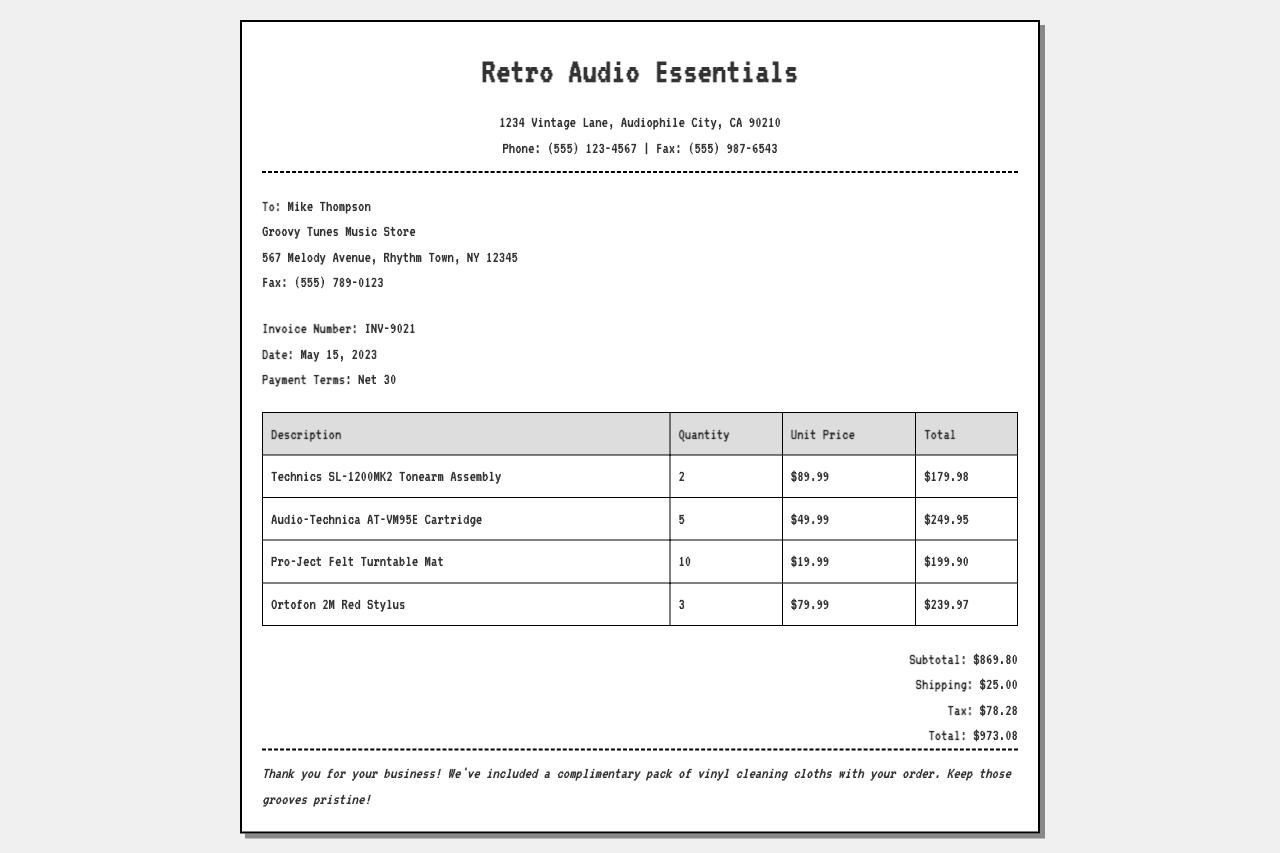What is the invoice number? The invoice number is prominently displayed in the document details.
Answer: INV-9021 What date was the invoice issued? The date of the invoice is given in the invoice details section.
Answer: May 15, 2023 Who is the recipient of the invoice? The recipient's name is listed as the first item in the recipient section.
Answer: Mike Thompson What is the subtotal amount? The subtotal amount is calculated and shown in the totals section.
Answer: $869.80 How many Audio-Technica AT-VM95E Cartridges were ordered? The quantity is indicated in the table under the specified product.
Answer: 5 What is the total amount due? The total is clearly stated in the totals section of the document.
Answer: $973.08 What is included as a complimentary item? The complimentary item is mentioned in the notes at the bottom of the document.
Answer: Vinyl cleaning cloths How much is the shipping cost? The shipping cost is detailed in the totals section of the invoice.
Answer: $25.00 What is the payment term stated in the invoice? The payment terms are explicitly mentioned in the invoice details section.
Answer: Net 30 